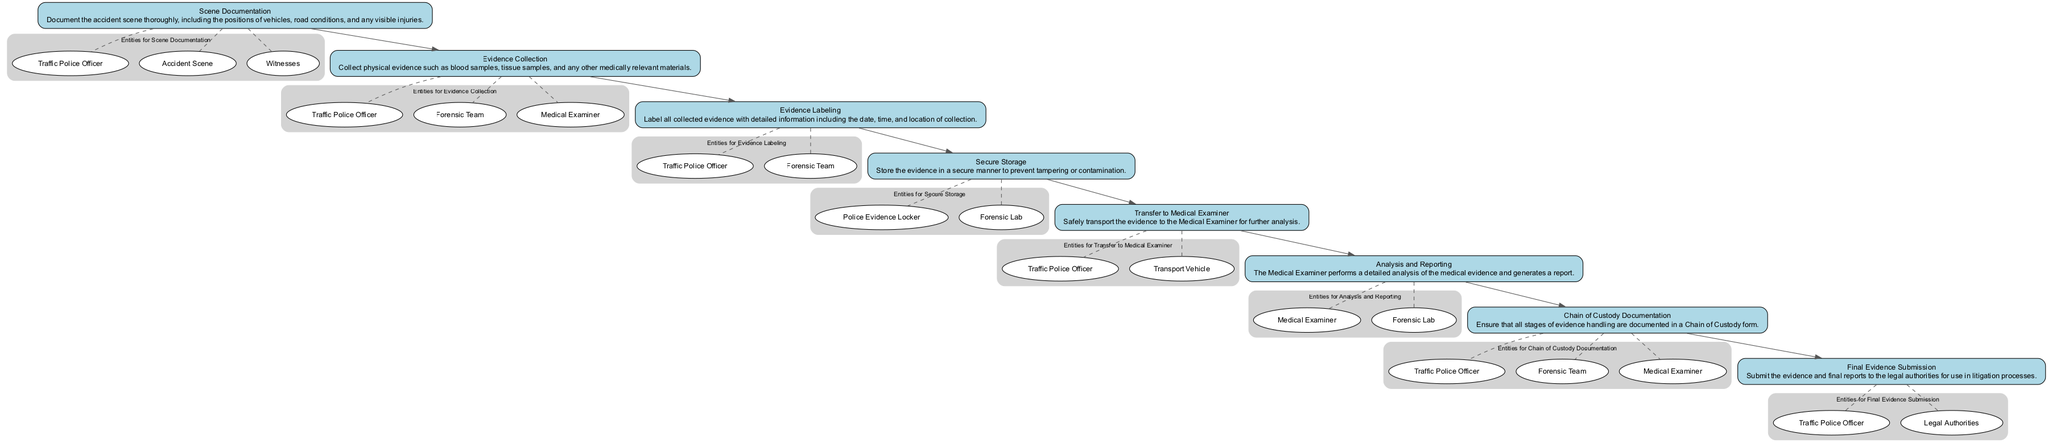What is the first step in the pathway? The first step listed in the diagram is "Scene Documentation", which is the initial action to be taken in the clinical pathway.
Answer: Scene Documentation How many total steps are there in the clinical pathway? By counting each individual step listed in the diagram, we find that there are eight distinct steps in total.
Answer: 8 Name the entities involved in "Evidence Collection". The step "Evidence Collection" lists the entities involved as "Traffic Police Officer", "Forensic Team", and "Medical Examiner", which are key participants in this action.
Answer: Traffic Police Officer, Forensic Team, Medical Examiner What step follows "Transfer to Medical Examiner"? The step that immediately follows "Transfer to Medical Examiner" in the diagram is "Analysis and Reporting", indicating the next action in the flow.
Answer: Analysis and Reporting Which step is responsible for storing evidence? The step designated for storing evidence as per the diagram is "Secure Storage", which focuses on preventing any tampering or contamination of collected evidence.
Answer: Secure Storage How many entities are involved in "Chain of Custody Documentation"? The step "Chain of Custody Documentation" includes three entities: "Traffic Police Officer," "Forensic Team," and "Medical Examiner," highlighting the collaboration required at this stage.
Answer: 3 What is the final action taken in this pathway? The last action in the clinical pathway, according to the diagram, is "Final Evidence Submission," which signifies the conclusion of the process where evidence is submitted to legal authorities.
Answer: Final Evidence Submission Which step involves transporting evidence? The step that specifically involves the transport of evidence is labeled "Transfer to Medical Examiner," indicating the activity of moving collected evidence for further analysis.
Answer: Transfer to Medical Examiner Which entities are involved in "Secure Storage"? The entities involved in "Secure Storage" are "Police Evidence Locker" and "Forensic Lab," both critical for ensuring the integrity of the stored evidence.
Answer: Police Evidence Locker, Forensic Lab 